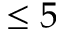<formula> <loc_0><loc_0><loc_500><loc_500>\leq 5</formula> 